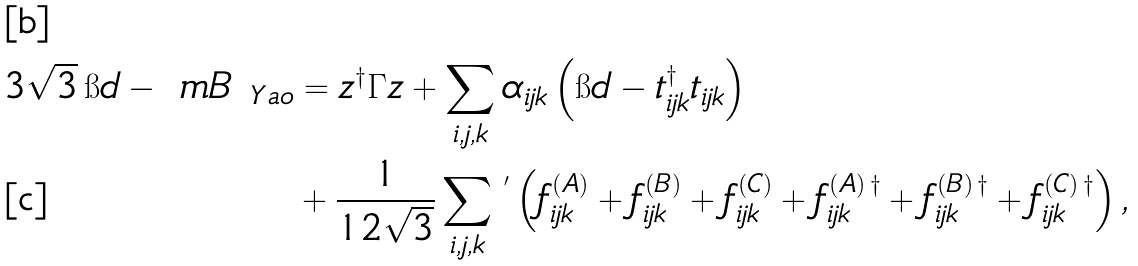<formula> <loc_0><loc_0><loc_500><loc_500>3 \sqrt { 3 } \, \i d - \ m B _ { \ Y a o } & = z ^ { \dagger } \Gamma z + \sum _ { i , j , k } \alpha _ { i j k } \left ( \i d - t _ { i j k } ^ { \dagger } t _ { i j k } \right ) \\ & + \frac { 1 } { 1 2 \sqrt { 3 } } \sum _ { i , j , k } \, ^ { ^ { \prime } } \left ( f ^ { ( A ) } _ { i j k } + f ^ { ( B ) } _ { i j k } + f ^ { ( C ) } _ { i j k } + f ^ { ( A ) \, \dagger } _ { i j k } + f ^ { ( B ) \, \dagger } _ { i j k } + f ^ { ( C ) \, \dagger } _ { i j k } \right ) ,</formula> 